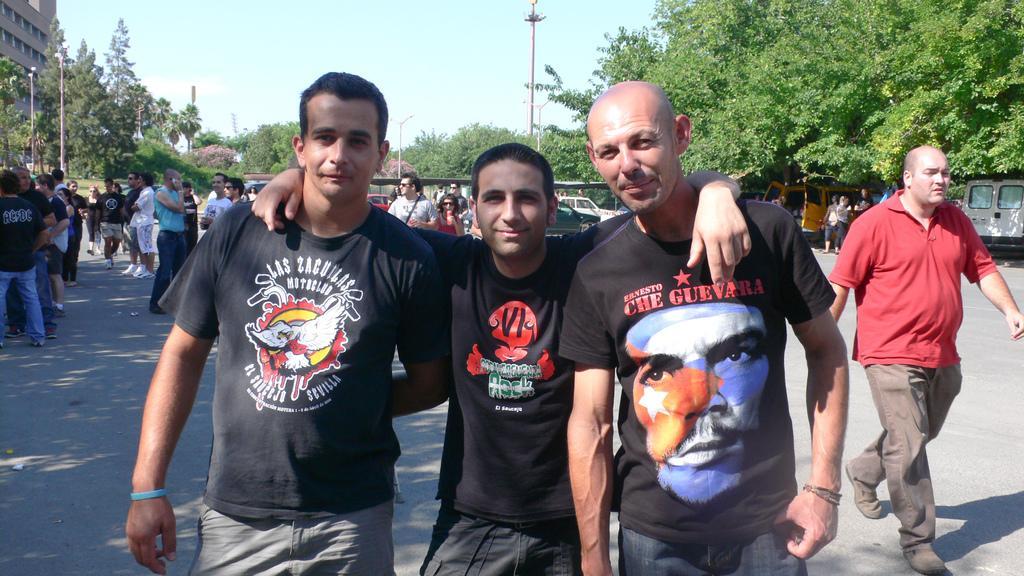Describe this image in one or two sentences. In the middle of the image we can see three persons. Here we can see people on the road. There are poles, vehicles, plants, trees, and a building. In the background there is sky. 